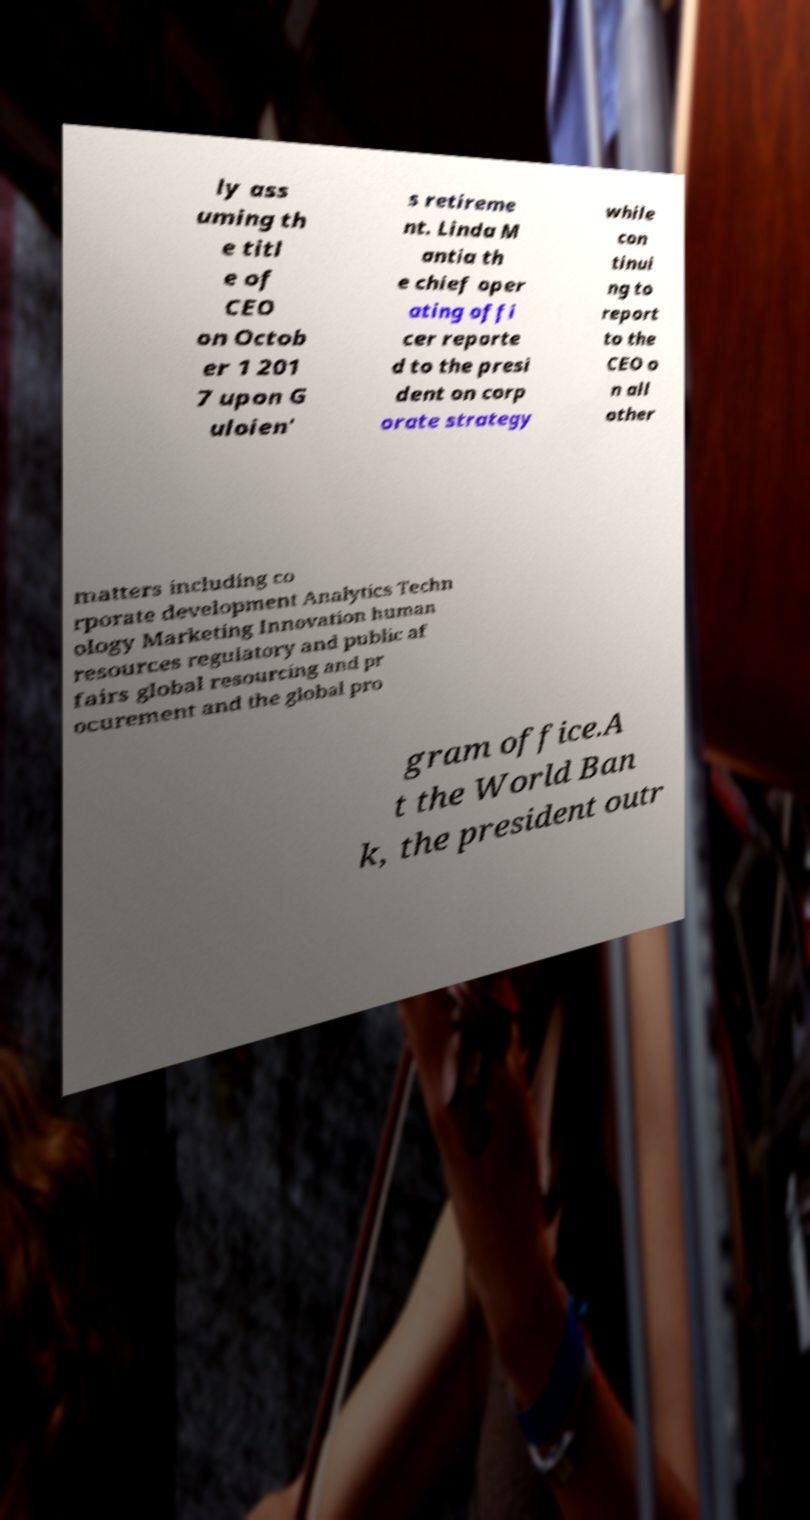Could you assist in decoding the text presented in this image and type it out clearly? ly ass uming th e titl e of CEO on Octob er 1 201 7 upon G uloien' s retireme nt. Linda M antia th e chief oper ating offi cer reporte d to the presi dent on corp orate strategy while con tinui ng to report to the CEO o n all other matters including co rporate development Analytics Techn ology Marketing Innovation human resources regulatory and public af fairs global resourcing and pr ocurement and the global pro gram office.A t the World Ban k, the president outr 